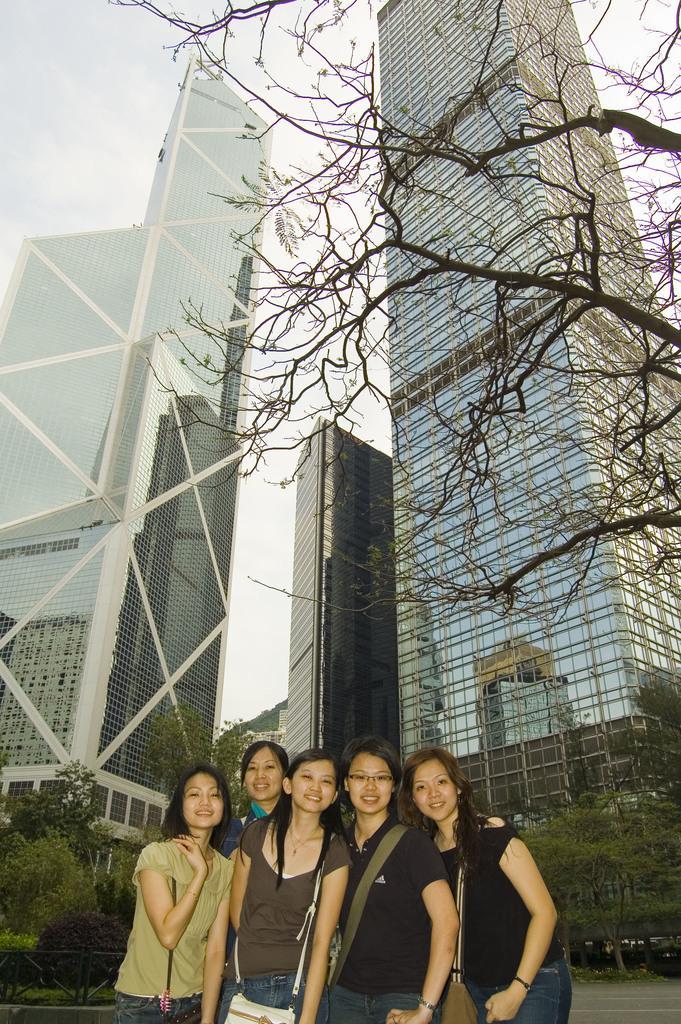In one or two sentences, can you explain what this image depicts? In the foreground of the picture we can see group of women. In the middle of the picture there are trees and buildings. At the top there is sky. 